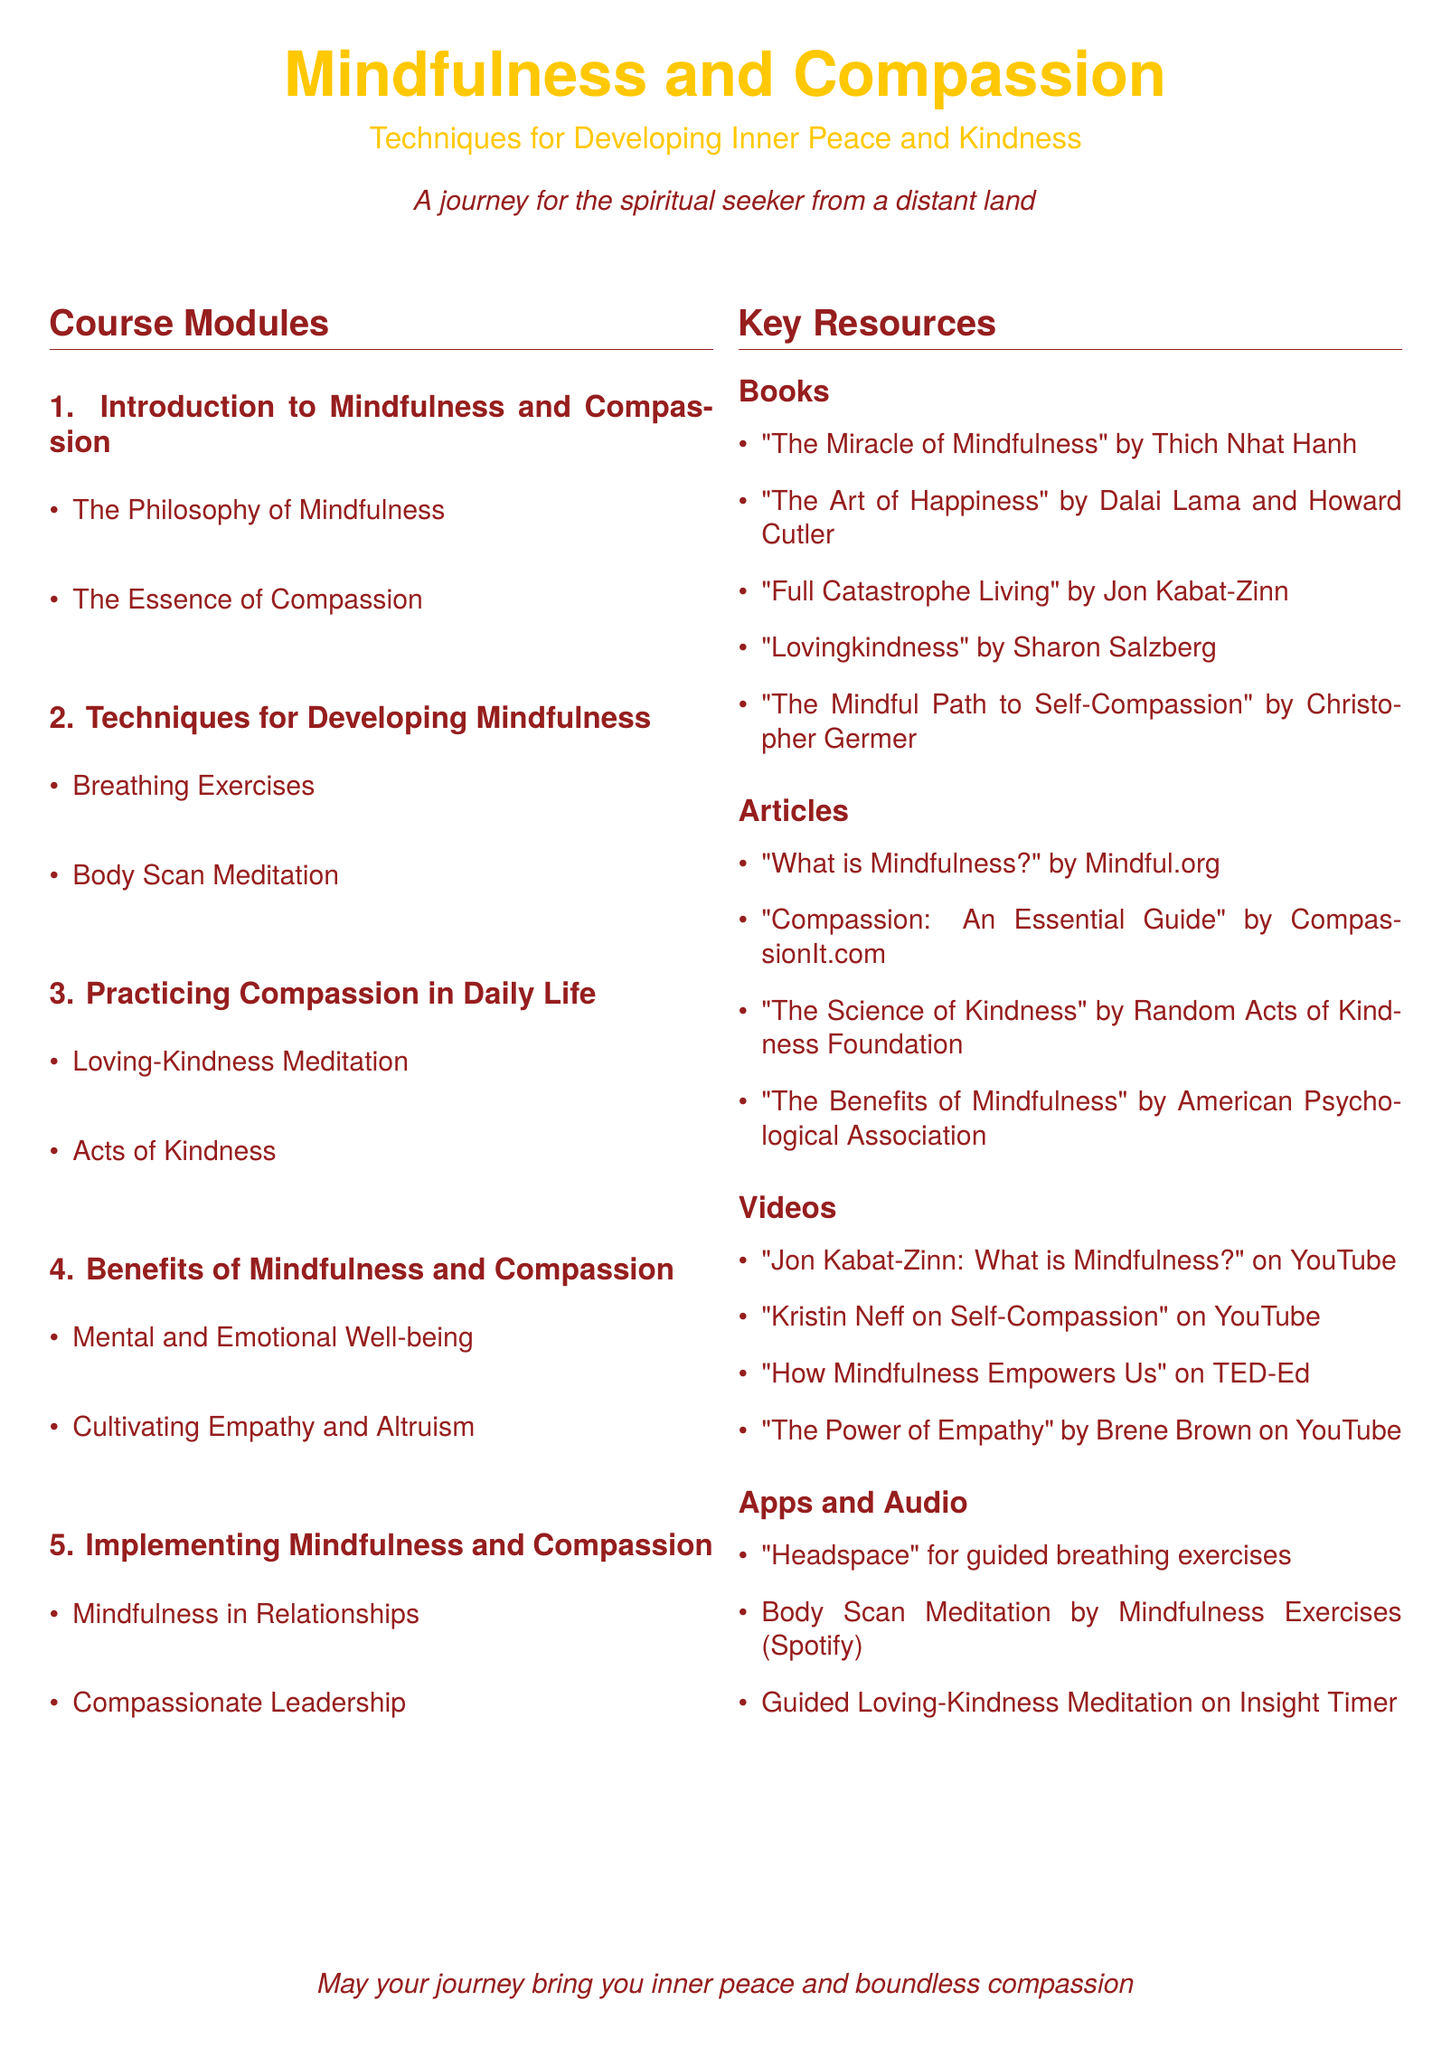What is the first module in the course? The first module is indicated in the syllabus as "Introduction to Mindfulness and Compassion."
Answer: Introduction to Mindfulness and Compassion Who is the author of "The Miracle of Mindfulness"? The syllabus lists Thich Nhat Hanh as the author of this book.
Answer: Thich Nhat Hanh How many sections are there in the course modules? The syllabus outlines a total of five sections, each focusing on different aspects of mindfulness and compassion.
Answer: 5 What is one of the key techniques for developing mindfulness? The syllabus includes "Breathing Exercises" as a technique for developing mindfulness.
Answer: Breathing Exercises What resource type is "Guided Loving-Kindness Meditation" categorized under? The syllabus identifies this resource as part of the "Apps and Audio" section.
Answer: Apps and Audio What is a benefit of mindfulness and compassion listed in the syllabus? The syllabus states "Mental and Emotional Well-being" as one of the benefits.
Answer: Mental and Emotional Well-being Which meditation practice is focused on loving-kindness? The course module discusses "Loving-Kindness Meditation" specifically for practicing compassion.
Answer: Loving-Kindness Meditation What type of resource is "How Mindfulness Empowers Us"? The syllabus categorizes this resource as a video available on TED-Ed.
Answer: Video 